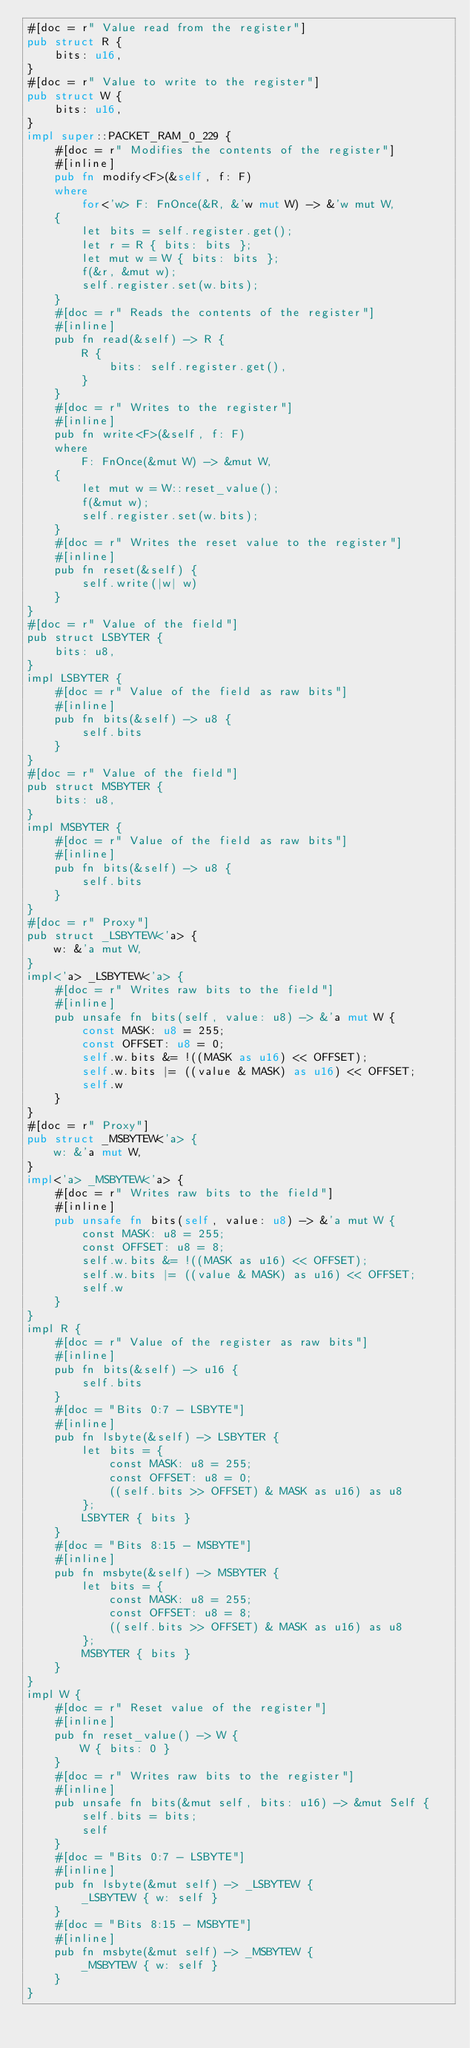Convert code to text. <code><loc_0><loc_0><loc_500><loc_500><_Rust_>#[doc = r" Value read from the register"]
pub struct R {
    bits: u16,
}
#[doc = r" Value to write to the register"]
pub struct W {
    bits: u16,
}
impl super::PACKET_RAM_0_229 {
    #[doc = r" Modifies the contents of the register"]
    #[inline]
    pub fn modify<F>(&self, f: F)
    where
        for<'w> F: FnOnce(&R, &'w mut W) -> &'w mut W,
    {
        let bits = self.register.get();
        let r = R { bits: bits };
        let mut w = W { bits: bits };
        f(&r, &mut w);
        self.register.set(w.bits);
    }
    #[doc = r" Reads the contents of the register"]
    #[inline]
    pub fn read(&self) -> R {
        R {
            bits: self.register.get(),
        }
    }
    #[doc = r" Writes to the register"]
    #[inline]
    pub fn write<F>(&self, f: F)
    where
        F: FnOnce(&mut W) -> &mut W,
    {
        let mut w = W::reset_value();
        f(&mut w);
        self.register.set(w.bits);
    }
    #[doc = r" Writes the reset value to the register"]
    #[inline]
    pub fn reset(&self) {
        self.write(|w| w)
    }
}
#[doc = r" Value of the field"]
pub struct LSBYTER {
    bits: u8,
}
impl LSBYTER {
    #[doc = r" Value of the field as raw bits"]
    #[inline]
    pub fn bits(&self) -> u8 {
        self.bits
    }
}
#[doc = r" Value of the field"]
pub struct MSBYTER {
    bits: u8,
}
impl MSBYTER {
    #[doc = r" Value of the field as raw bits"]
    #[inline]
    pub fn bits(&self) -> u8 {
        self.bits
    }
}
#[doc = r" Proxy"]
pub struct _LSBYTEW<'a> {
    w: &'a mut W,
}
impl<'a> _LSBYTEW<'a> {
    #[doc = r" Writes raw bits to the field"]
    #[inline]
    pub unsafe fn bits(self, value: u8) -> &'a mut W {
        const MASK: u8 = 255;
        const OFFSET: u8 = 0;
        self.w.bits &= !((MASK as u16) << OFFSET);
        self.w.bits |= ((value & MASK) as u16) << OFFSET;
        self.w
    }
}
#[doc = r" Proxy"]
pub struct _MSBYTEW<'a> {
    w: &'a mut W,
}
impl<'a> _MSBYTEW<'a> {
    #[doc = r" Writes raw bits to the field"]
    #[inline]
    pub unsafe fn bits(self, value: u8) -> &'a mut W {
        const MASK: u8 = 255;
        const OFFSET: u8 = 8;
        self.w.bits &= !((MASK as u16) << OFFSET);
        self.w.bits |= ((value & MASK) as u16) << OFFSET;
        self.w
    }
}
impl R {
    #[doc = r" Value of the register as raw bits"]
    #[inline]
    pub fn bits(&self) -> u16 {
        self.bits
    }
    #[doc = "Bits 0:7 - LSBYTE"]
    #[inline]
    pub fn lsbyte(&self) -> LSBYTER {
        let bits = {
            const MASK: u8 = 255;
            const OFFSET: u8 = 0;
            ((self.bits >> OFFSET) & MASK as u16) as u8
        };
        LSBYTER { bits }
    }
    #[doc = "Bits 8:15 - MSBYTE"]
    #[inline]
    pub fn msbyte(&self) -> MSBYTER {
        let bits = {
            const MASK: u8 = 255;
            const OFFSET: u8 = 8;
            ((self.bits >> OFFSET) & MASK as u16) as u8
        };
        MSBYTER { bits }
    }
}
impl W {
    #[doc = r" Reset value of the register"]
    #[inline]
    pub fn reset_value() -> W {
        W { bits: 0 }
    }
    #[doc = r" Writes raw bits to the register"]
    #[inline]
    pub unsafe fn bits(&mut self, bits: u16) -> &mut Self {
        self.bits = bits;
        self
    }
    #[doc = "Bits 0:7 - LSBYTE"]
    #[inline]
    pub fn lsbyte(&mut self) -> _LSBYTEW {
        _LSBYTEW { w: self }
    }
    #[doc = "Bits 8:15 - MSBYTE"]
    #[inline]
    pub fn msbyte(&mut self) -> _MSBYTEW {
        _MSBYTEW { w: self }
    }
}
</code> 